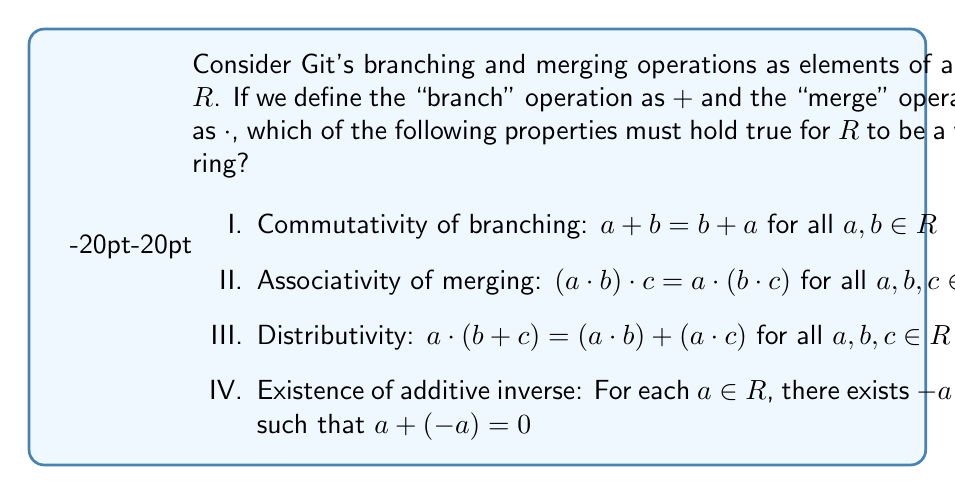Show me your answer to this math problem. To analyze this question, we need to consider the properties of Git's branching and merging operations and how they relate to ring theory:

1. Commutativity of branching (Property I):
   In Git, the order of creating branches doesn't matter. Creating branch A then B is equivalent to creating branch B then A. Therefore, this property holds true.

2. Associativity of merging (Property II):
   When merging multiple branches, the order of merging doesn't affect the final result. Merging A into B, then merging the result into C is equivalent to merging B into C, then merging A into the result. This property holds true.

3. Distributivity (Property III):
   This property doesn't always hold in Git. Merging a branch A into the result of branching B and C is not always equivalent to merging A into B and A into C separately, then combining the results. The outcome depends on the specific changes in each branch.

4. Existence of additive inverse (Property IV):
   In Git, there's no direct operation that "undoes" a branch creation. While you can delete a branch, it doesn't necessarily reverse the state to what it was before the branch was created, especially if commits were made on that branch. Therefore, this property doesn't hold.

For a valid ring, all of these properties must hold except for the commutativity of multiplication (merging in this case). However, we've found that not all of these properties are true for Git operations.
Answer: II only. Only the associativity of merging (Property II) must hold true for $R$ to be a valid ring representing Git's branching and merging operations. 